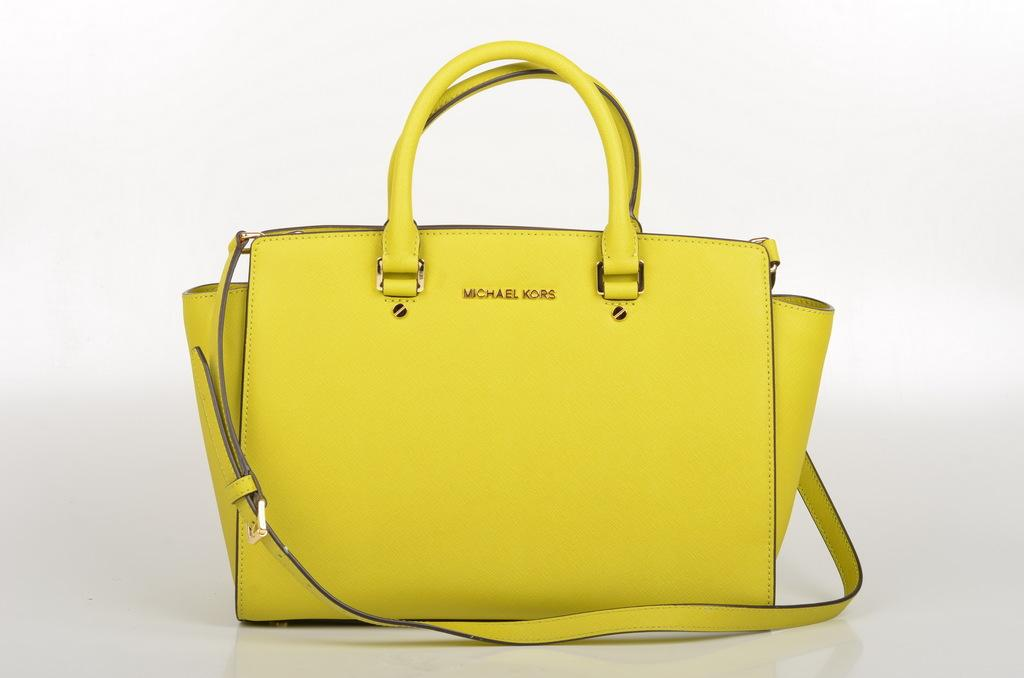What is the color of the bag in the image? The bag is yellow in color. What feature does the bag have for carrying purposes? The bag has a strap. Can you hear the duck quacking in the image? There is no duck present in the image, so it is not possible to hear any quacking. 